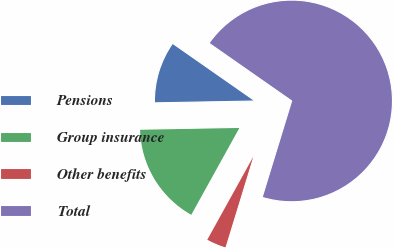Convert chart to OTSL. <chart><loc_0><loc_0><loc_500><loc_500><pie_chart><fcel>Pensions<fcel>Group insurance<fcel>Other benefits<fcel>Total<nl><fcel>9.99%<fcel>16.66%<fcel>3.32%<fcel>70.03%<nl></chart> 